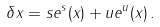<formula> <loc_0><loc_0><loc_500><loc_500>\delta { x } = { s } { e } ^ { s } ( { x } ) + { u } { e } ^ { u } ( { x } ) \, .</formula> 